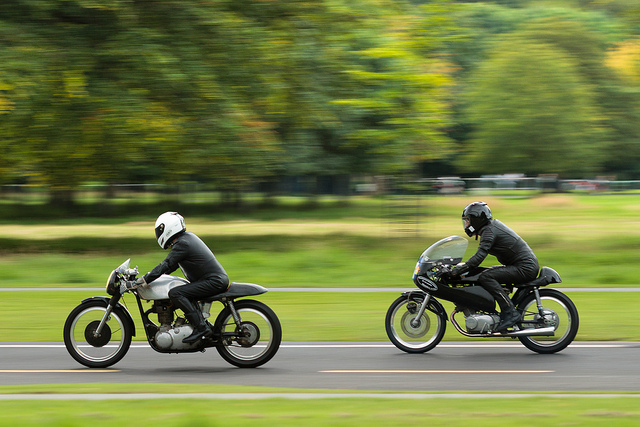What's the setting of this photograph? The photograph captures the riders on a roadway adjacent to a lush green park, which might suggest a suburban setting outside a city or a designated racing area for motor enthusiasts to enjoy a sprint. 